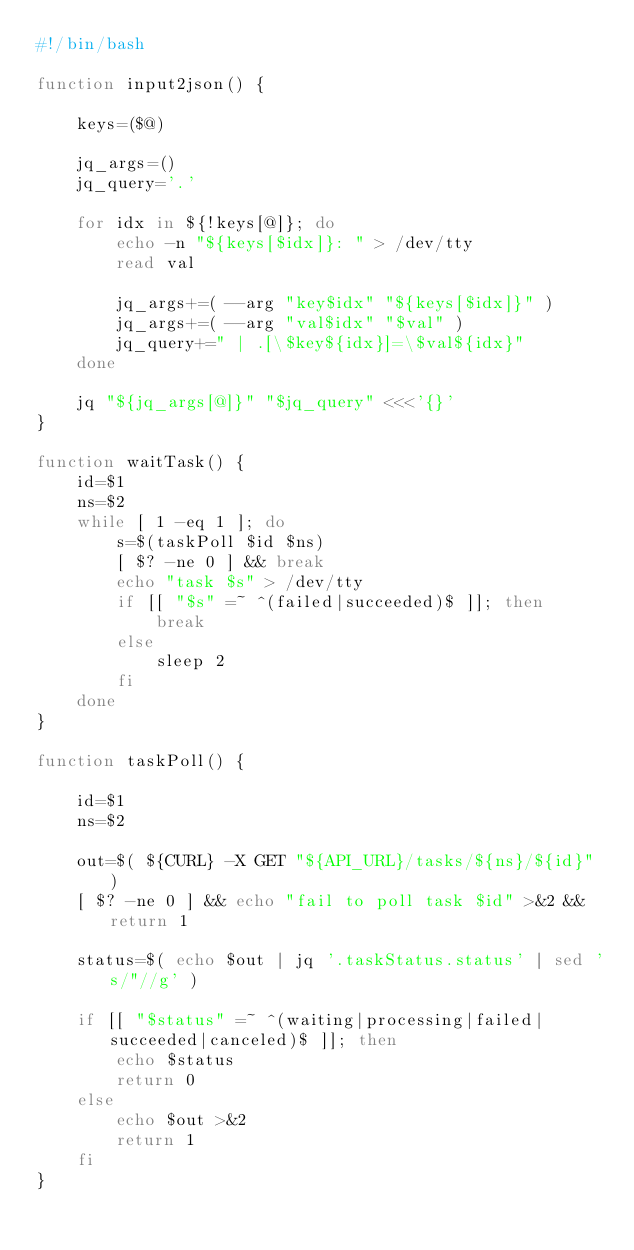Convert code to text. <code><loc_0><loc_0><loc_500><loc_500><_Bash_>#!/bin/bash

function input2json() {

    keys=($@)

    jq_args=()
    jq_query='.'

    for idx in ${!keys[@]}; do
        echo -n "${keys[$idx]}: " > /dev/tty
        read val

        jq_args+=( --arg "key$idx" "${keys[$idx]}" )
        jq_args+=( --arg "val$idx" "$val" )
        jq_query+=" | .[\$key${idx}]=\$val${idx}"
    done

    jq "${jq_args[@]}" "$jq_query" <<<'{}'
}

function waitTask() {
    id=$1
    ns=$2
    while [ 1 -eq 1 ]; do
        s=$(taskPoll $id $ns)
        [ $? -ne 0 ] && break
        echo "task $s" > /dev/tty
        if [[ "$s" =~ ^(failed|succeeded)$ ]]; then
            break
        else
            sleep 2
        fi
    done
}

function taskPoll() {

    id=$1
    ns=$2

    out=$( ${CURL} -X GET "${API_URL}/tasks/${ns}/${id}" )
    [ $? -ne 0 ] && echo "fail to poll task $id" >&2 && return 1

    status=$( echo $out | jq '.taskStatus.status' | sed 's/"//g' )

    if [[ "$status" =~ ^(waiting|processing|failed|succeeded|canceled)$ ]]; then
        echo $status
        return 0
    else
        echo $out >&2
        return 1
    fi
}
</code> 